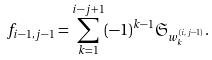<formula> <loc_0><loc_0><loc_500><loc_500>f _ { i - 1 , j - 1 } = \sum _ { k = 1 } ^ { i - j + 1 } ( - 1 ) ^ { k - 1 } \mathfrak { S } _ { w _ { k } ^ { ( i , j - 1 ) } } .</formula> 